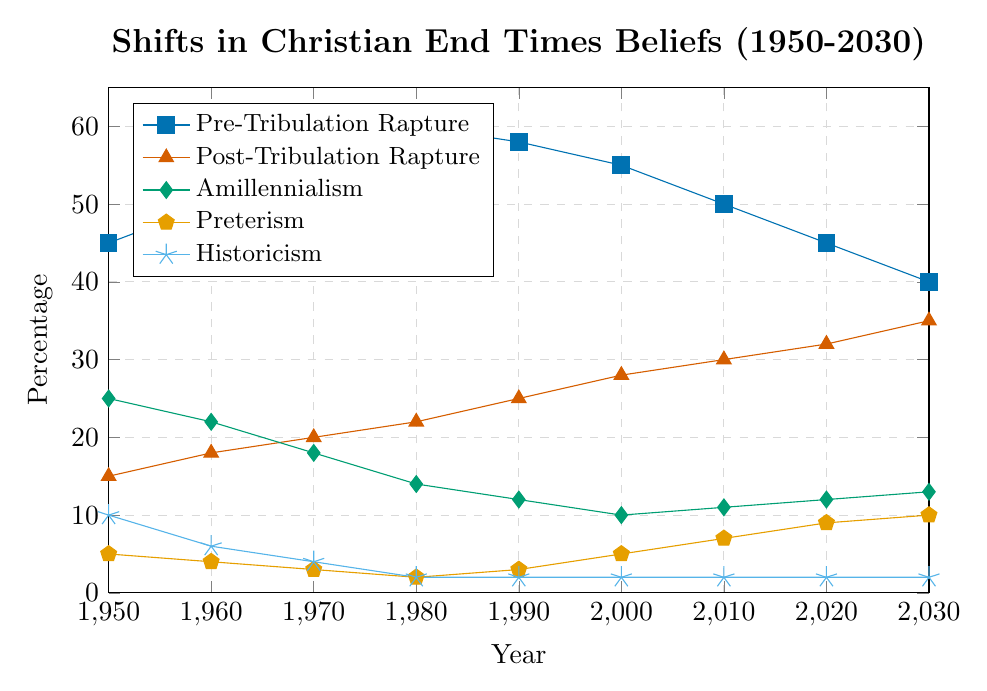Which belief was more prevalent in 1960, Pre-Tribulation Rapture or Post-Tribulation Rapture? In 1960, Pre-Tribulation Rapture had a higher percentage (50%) compared to Post-Tribulation Rapture (18%).
Answer: Pre-Tribulation Rapture What is the trend in the percentage of Christians who believe in Amillennialism from 1950 to 2030? Amillennialism shows a decreasing trend from 25% in 1950 to 10% in 2000, then increasing mildly to 13% by 2030.
Answer: Decreasing until 2000, then slightly increasing Which interpretation saw the most significant decrease from 1950 to 2030? Pre-Tribulation Rapture saw a decrease from 45% in 1950 to 40% in 2030, while Amillennialism dropped from 25% to 13%. Comparing all beliefs, Amillennialism's relative drop proportion appears significant.
Answer: Amillennialism Compare the trends of Pretribulation Rapture and Preterism from 1950 to 2030. Pretribulation Rapture increased initially from 45% in 1950 to 60% in 1980 but then decreased to 40% by 2030. Preterism started at 5% in 1950 and showed a steady increase up to 10% by 2030.
Answer: Pretribulation Rapture: Increase, then decrease; Preterism: Steady increase What belief had the highest and lowest percentage in 1980? In 1980, Pre-Tribulation Rapture had the highest percentage at 60%, and Historicism had the lowest at 2%.
Answer: Highest: Pre-Tribulation Rapture, Lowest: Historicism In which decade did Post-Tribulation Rapture surpass 30%? Post-Tribulation Rapture surpassed 30% in the decade of 2010-2020.
Answer: 2010-2020 Calculate the average percentage of Preterism beliefs over all the recorded years. The percentages for Preterism from 1950 to 2030 are 5, 4, 3, 2, 3, 5, 7, 9, and 10. Summing them gives 48, and there are 9 data points, so the average is 48/9 = 5.33%.
Answer: 5.33% How does the percentage of Historicism beliefs in 1990 compare to that in 2030? The percentage remained the same at 2% in both 1990 and 2030.
Answer: Equal, at 2% Between which two consecutive decades did Amillennialism see a resurgence in belief? Amillennialism saw a resurgence between 2000 and 2010, increasing from 10% to 11%.
Answer: 2000-2010 